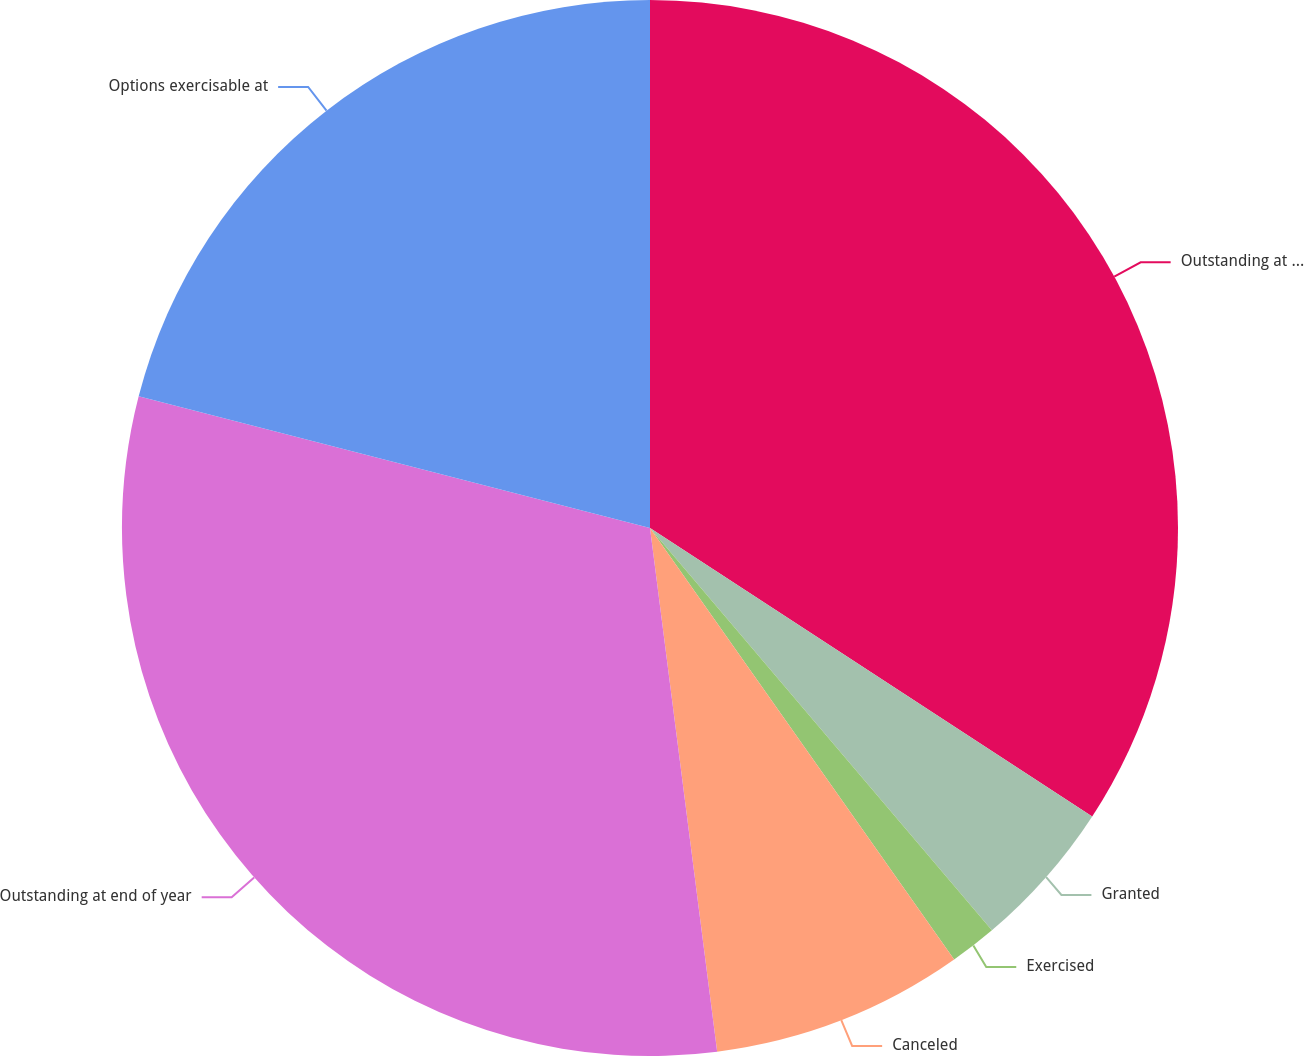<chart> <loc_0><loc_0><loc_500><loc_500><pie_chart><fcel>Outstanding at beginning of<fcel>Granted<fcel>Exercised<fcel>Canceled<fcel>Outstanding at end of year<fcel>Options exercisable at<nl><fcel>34.2%<fcel>4.59%<fcel>1.44%<fcel>7.74%<fcel>31.04%<fcel>20.99%<nl></chart> 